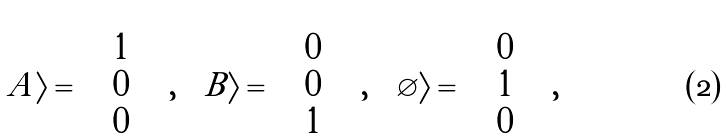Convert formula to latex. <formula><loc_0><loc_0><loc_500><loc_500>| A \rangle = \left ( \begin{array} { c } 1 \\ 0 \\ 0 \end{array} \right ) , \quad | B \rangle = \left ( \begin{array} { c } 0 \\ 0 \\ 1 \end{array} \right ) , \quad | \varnothing \rangle = \left ( \begin{array} { c } 0 \\ 1 \\ 0 \end{array} \right ) ,</formula> 